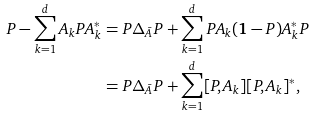Convert formula to latex. <formula><loc_0><loc_0><loc_500><loc_500>P - \sum _ { k = 1 } ^ { d } A _ { k } P A _ { k } ^ { * } & = P \Delta _ { \bar { A } } P + \sum _ { k = 1 } ^ { d } P A _ { k } ( \mathbf 1 - P ) A _ { k } ^ { * } P \\ & = P \Delta _ { \bar { A } } P + \sum _ { k = 1 } ^ { d } [ P , A _ { k } ] [ P , A _ { k } ] ^ { * } ,</formula> 